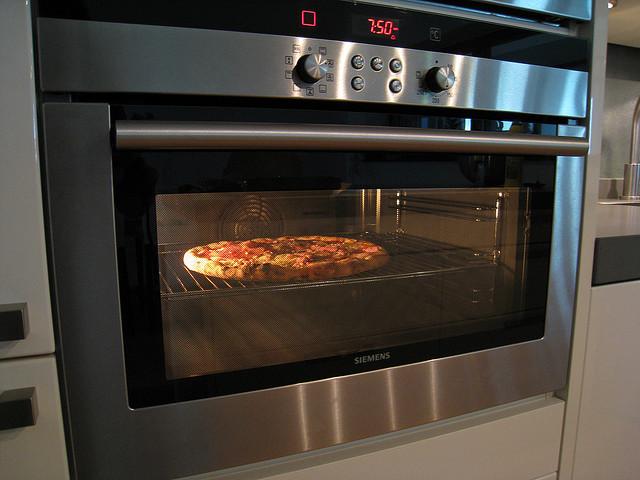Was this pizza ordered from Domino's?
Be succinct. No. Is the oven open or closed?
Short answer required. Closed. How long until this pizza is done?
Keep it brief. 7:50 minutes. What temp is the oven at?
Write a very short answer. 750. 